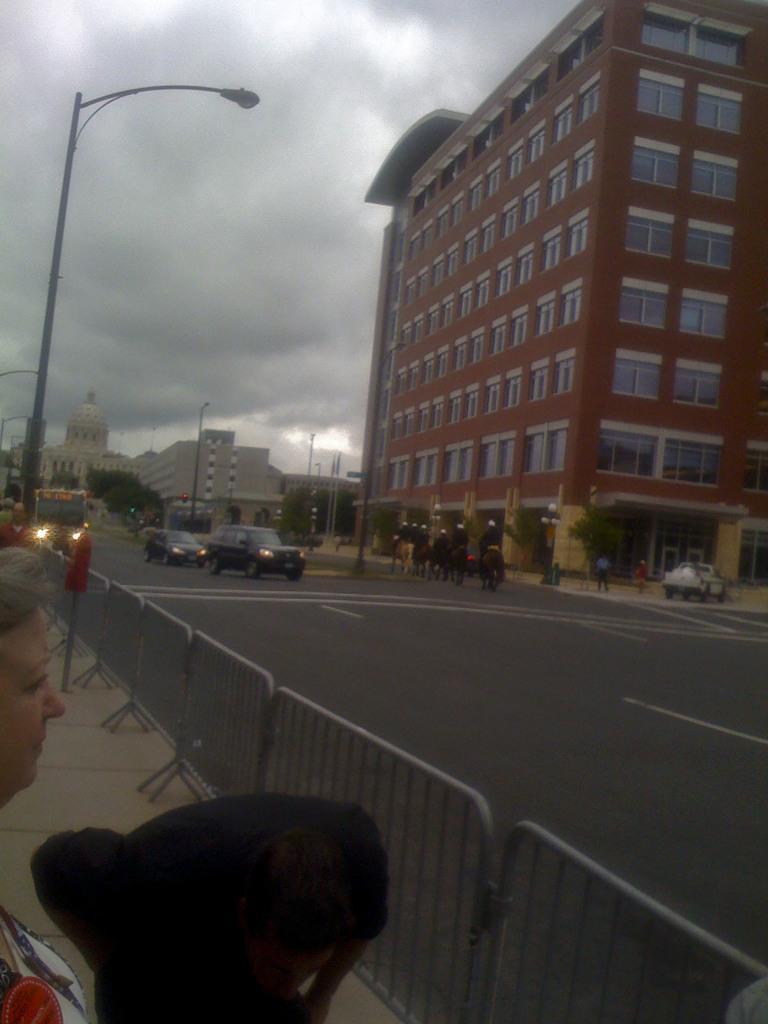Describe this image in one or two sentences. At the bottom of the image we can see persons near the barricades. In the background of the image there are buildings, vehicles, poles, some people, animals and the sky. 